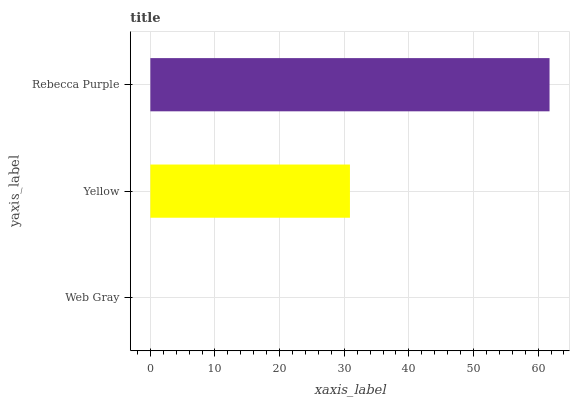Is Web Gray the minimum?
Answer yes or no. Yes. Is Rebecca Purple the maximum?
Answer yes or no. Yes. Is Yellow the minimum?
Answer yes or no. No. Is Yellow the maximum?
Answer yes or no. No. Is Yellow greater than Web Gray?
Answer yes or no. Yes. Is Web Gray less than Yellow?
Answer yes or no. Yes. Is Web Gray greater than Yellow?
Answer yes or no. No. Is Yellow less than Web Gray?
Answer yes or no. No. Is Yellow the high median?
Answer yes or no. Yes. Is Yellow the low median?
Answer yes or no. Yes. Is Rebecca Purple the high median?
Answer yes or no. No. Is Web Gray the low median?
Answer yes or no. No. 